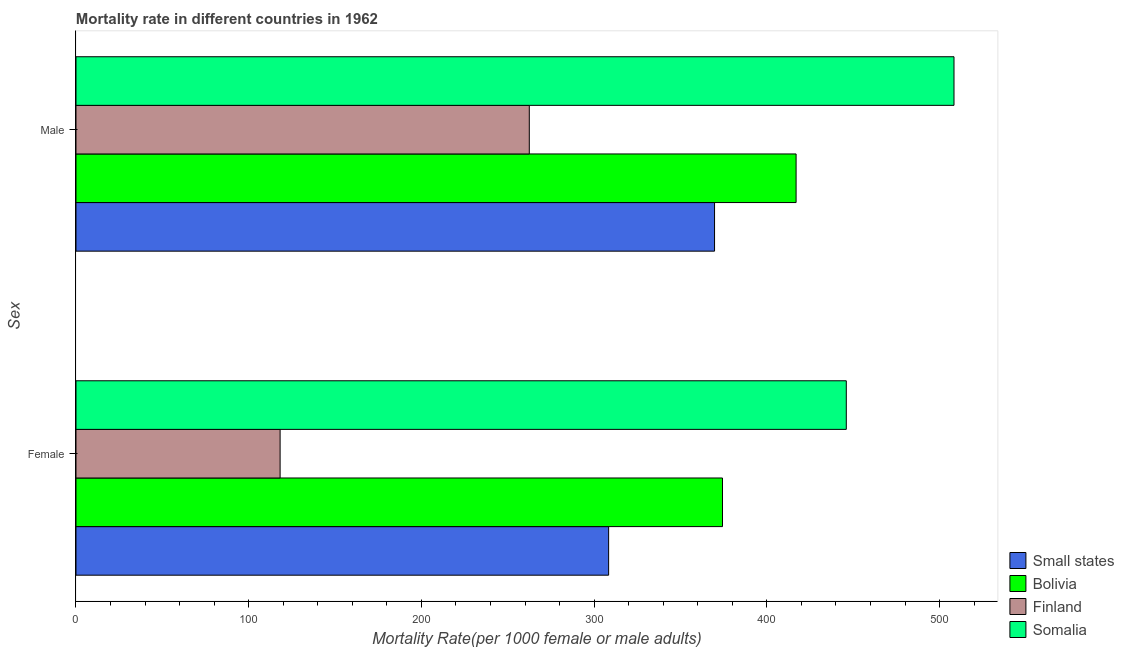How many groups of bars are there?
Your answer should be compact. 2. Are the number of bars per tick equal to the number of legend labels?
Provide a short and direct response. Yes. Are the number of bars on each tick of the Y-axis equal?
Offer a very short reply. Yes. What is the male mortality rate in Somalia?
Offer a terse response. 508.35. Across all countries, what is the maximum male mortality rate?
Ensure brevity in your answer.  508.35. Across all countries, what is the minimum male mortality rate?
Provide a succinct answer. 262.45. In which country was the female mortality rate maximum?
Offer a very short reply. Somalia. In which country was the male mortality rate minimum?
Your answer should be compact. Finland. What is the total female mortality rate in the graph?
Offer a terse response. 1246.88. What is the difference between the female mortality rate in Finland and that in Bolivia?
Provide a succinct answer. -256.13. What is the difference between the female mortality rate in Bolivia and the male mortality rate in Somalia?
Your answer should be very brief. -134.03. What is the average male mortality rate per country?
Offer a terse response. 389.36. What is the difference between the female mortality rate and male mortality rate in Finland?
Your response must be concise. -144.27. What is the ratio of the male mortality rate in Small states to that in Finland?
Ensure brevity in your answer.  1.41. Is the male mortality rate in Somalia less than that in Small states?
Provide a succinct answer. No. In how many countries, is the male mortality rate greater than the average male mortality rate taken over all countries?
Provide a short and direct response. 2. What does the 2nd bar from the top in Male represents?
Provide a succinct answer. Finland. What does the 4th bar from the bottom in Female represents?
Keep it short and to the point. Somalia. How many bars are there?
Ensure brevity in your answer.  8. Are all the bars in the graph horizontal?
Your response must be concise. Yes. What is the difference between two consecutive major ticks on the X-axis?
Give a very brief answer. 100. Does the graph contain grids?
Offer a very short reply. No. Where does the legend appear in the graph?
Your answer should be compact. Bottom right. What is the title of the graph?
Your response must be concise. Mortality rate in different countries in 1962. What is the label or title of the X-axis?
Offer a terse response. Mortality Rate(per 1000 female or male adults). What is the label or title of the Y-axis?
Provide a short and direct response. Sex. What is the Mortality Rate(per 1000 female or male adults) of Small states in Female?
Keep it short and to the point. 308.38. What is the Mortality Rate(per 1000 female or male adults) in Bolivia in Female?
Ensure brevity in your answer.  374.32. What is the Mortality Rate(per 1000 female or male adults) of Finland in Female?
Your answer should be compact. 118.18. What is the Mortality Rate(per 1000 female or male adults) in Somalia in Female?
Your answer should be very brief. 446. What is the Mortality Rate(per 1000 female or male adults) of Small states in Male?
Provide a short and direct response. 369.72. What is the Mortality Rate(per 1000 female or male adults) of Bolivia in Male?
Keep it short and to the point. 416.93. What is the Mortality Rate(per 1000 female or male adults) of Finland in Male?
Provide a succinct answer. 262.45. What is the Mortality Rate(per 1000 female or male adults) of Somalia in Male?
Your response must be concise. 508.35. Across all Sex, what is the maximum Mortality Rate(per 1000 female or male adults) in Small states?
Your answer should be very brief. 369.72. Across all Sex, what is the maximum Mortality Rate(per 1000 female or male adults) of Bolivia?
Your answer should be compact. 416.93. Across all Sex, what is the maximum Mortality Rate(per 1000 female or male adults) in Finland?
Offer a very short reply. 262.45. Across all Sex, what is the maximum Mortality Rate(per 1000 female or male adults) of Somalia?
Offer a terse response. 508.35. Across all Sex, what is the minimum Mortality Rate(per 1000 female or male adults) of Small states?
Provide a short and direct response. 308.38. Across all Sex, what is the minimum Mortality Rate(per 1000 female or male adults) of Bolivia?
Ensure brevity in your answer.  374.32. Across all Sex, what is the minimum Mortality Rate(per 1000 female or male adults) in Finland?
Your answer should be very brief. 118.18. Across all Sex, what is the minimum Mortality Rate(per 1000 female or male adults) in Somalia?
Provide a short and direct response. 446. What is the total Mortality Rate(per 1000 female or male adults) in Small states in the graph?
Your response must be concise. 678.1. What is the total Mortality Rate(per 1000 female or male adults) in Bolivia in the graph?
Make the answer very short. 791.24. What is the total Mortality Rate(per 1000 female or male adults) of Finland in the graph?
Provide a succinct answer. 380.64. What is the total Mortality Rate(per 1000 female or male adults) of Somalia in the graph?
Your answer should be compact. 954.35. What is the difference between the Mortality Rate(per 1000 female or male adults) of Small states in Female and that in Male?
Your answer should be very brief. -61.33. What is the difference between the Mortality Rate(per 1000 female or male adults) of Bolivia in Female and that in Male?
Provide a short and direct response. -42.61. What is the difference between the Mortality Rate(per 1000 female or male adults) in Finland in Female and that in Male?
Provide a short and direct response. -144.27. What is the difference between the Mortality Rate(per 1000 female or male adults) of Somalia in Female and that in Male?
Offer a very short reply. -62.36. What is the difference between the Mortality Rate(per 1000 female or male adults) in Small states in Female and the Mortality Rate(per 1000 female or male adults) in Bolivia in Male?
Ensure brevity in your answer.  -108.54. What is the difference between the Mortality Rate(per 1000 female or male adults) in Small states in Female and the Mortality Rate(per 1000 female or male adults) in Finland in Male?
Offer a terse response. 45.93. What is the difference between the Mortality Rate(per 1000 female or male adults) in Small states in Female and the Mortality Rate(per 1000 female or male adults) in Somalia in Male?
Keep it short and to the point. -199.97. What is the difference between the Mortality Rate(per 1000 female or male adults) of Bolivia in Female and the Mortality Rate(per 1000 female or male adults) of Finland in Male?
Make the answer very short. 111.86. What is the difference between the Mortality Rate(per 1000 female or male adults) in Bolivia in Female and the Mortality Rate(per 1000 female or male adults) in Somalia in Male?
Offer a very short reply. -134.03. What is the difference between the Mortality Rate(per 1000 female or male adults) in Finland in Female and the Mortality Rate(per 1000 female or male adults) in Somalia in Male?
Your response must be concise. -390.17. What is the average Mortality Rate(per 1000 female or male adults) of Small states per Sex?
Your answer should be compact. 339.05. What is the average Mortality Rate(per 1000 female or male adults) in Bolivia per Sex?
Offer a very short reply. 395.62. What is the average Mortality Rate(per 1000 female or male adults) of Finland per Sex?
Give a very brief answer. 190.32. What is the average Mortality Rate(per 1000 female or male adults) in Somalia per Sex?
Your answer should be very brief. 477.17. What is the difference between the Mortality Rate(per 1000 female or male adults) of Small states and Mortality Rate(per 1000 female or male adults) of Bolivia in Female?
Provide a succinct answer. -65.93. What is the difference between the Mortality Rate(per 1000 female or male adults) of Small states and Mortality Rate(per 1000 female or male adults) of Finland in Female?
Provide a short and direct response. 190.2. What is the difference between the Mortality Rate(per 1000 female or male adults) of Small states and Mortality Rate(per 1000 female or male adults) of Somalia in Female?
Provide a short and direct response. -137.61. What is the difference between the Mortality Rate(per 1000 female or male adults) in Bolivia and Mortality Rate(per 1000 female or male adults) in Finland in Female?
Offer a very short reply. 256.13. What is the difference between the Mortality Rate(per 1000 female or male adults) in Bolivia and Mortality Rate(per 1000 female or male adults) in Somalia in Female?
Offer a terse response. -71.68. What is the difference between the Mortality Rate(per 1000 female or male adults) in Finland and Mortality Rate(per 1000 female or male adults) in Somalia in Female?
Offer a terse response. -327.81. What is the difference between the Mortality Rate(per 1000 female or male adults) of Small states and Mortality Rate(per 1000 female or male adults) of Bolivia in Male?
Provide a short and direct response. -47.21. What is the difference between the Mortality Rate(per 1000 female or male adults) in Small states and Mortality Rate(per 1000 female or male adults) in Finland in Male?
Your answer should be very brief. 107.26. What is the difference between the Mortality Rate(per 1000 female or male adults) of Small states and Mortality Rate(per 1000 female or male adults) of Somalia in Male?
Offer a very short reply. -138.64. What is the difference between the Mortality Rate(per 1000 female or male adults) of Bolivia and Mortality Rate(per 1000 female or male adults) of Finland in Male?
Offer a terse response. 154.47. What is the difference between the Mortality Rate(per 1000 female or male adults) in Bolivia and Mortality Rate(per 1000 female or male adults) in Somalia in Male?
Give a very brief answer. -91.42. What is the difference between the Mortality Rate(per 1000 female or male adults) in Finland and Mortality Rate(per 1000 female or male adults) in Somalia in Male?
Offer a terse response. -245.9. What is the ratio of the Mortality Rate(per 1000 female or male adults) of Small states in Female to that in Male?
Your answer should be very brief. 0.83. What is the ratio of the Mortality Rate(per 1000 female or male adults) of Bolivia in Female to that in Male?
Provide a short and direct response. 0.9. What is the ratio of the Mortality Rate(per 1000 female or male adults) in Finland in Female to that in Male?
Give a very brief answer. 0.45. What is the ratio of the Mortality Rate(per 1000 female or male adults) in Somalia in Female to that in Male?
Offer a terse response. 0.88. What is the difference between the highest and the second highest Mortality Rate(per 1000 female or male adults) of Small states?
Your response must be concise. 61.33. What is the difference between the highest and the second highest Mortality Rate(per 1000 female or male adults) of Bolivia?
Your response must be concise. 42.61. What is the difference between the highest and the second highest Mortality Rate(per 1000 female or male adults) in Finland?
Your answer should be compact. 144.27. What is the difference between the highest and the second highest Mortality Rate(per 1000 female or male adults) of Somalia?
Make the answer very short. 62.36. What is the difference between the highest and the lowest Mortality Rate(per 1000 female or male adults) of Small states?
Offer a very short reply. 61.33. What is the difference between the highest and the lowest Mortality Rate(per 1000 female or male adults) of Bolivia?
Your response must be concise. 42.61. What is the difference between the highest and the lowest Mortality Rate(per 1000 female or male adults) of Finland?
Offer a terse response. 144.27. What is the difference between the highest and the lowest Mortality Rate(per 1000 female or male adults) of Somalia?
Your answer should be very brief. 62.36. 